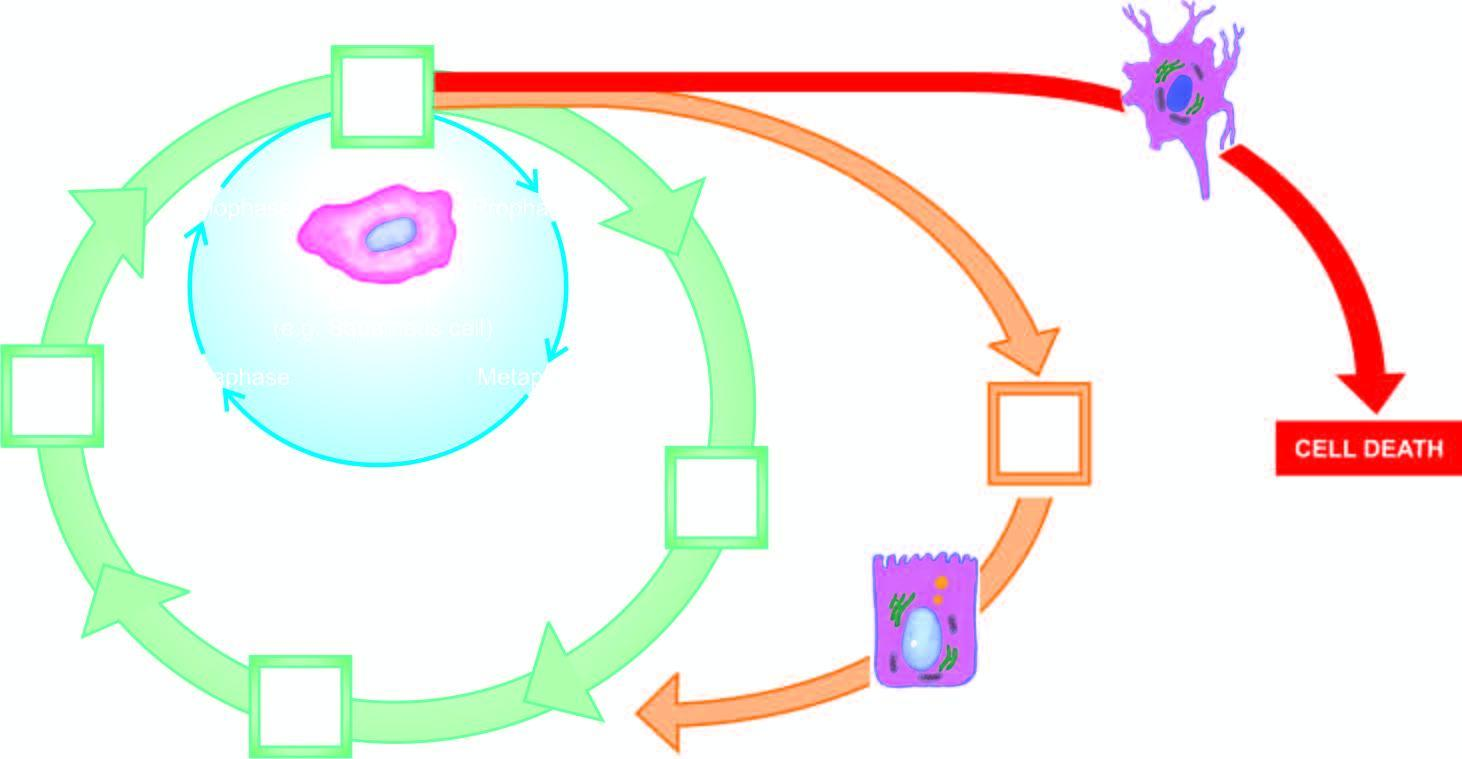what represents cell cycle for permanent cells?
Answer the question using a single word or phrase. Circle shown with red line 